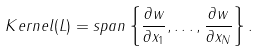Convert formula to latex. <formula><loc_0><loc_0><loc_500><loc_500>K e r n e l ( L ) = s p a n \left \{ \frac { \partial w } { \partial x _ { 1 } } , \dots , \frac { \partial w } { \partial x _ { N } } \right \} .</formula> 